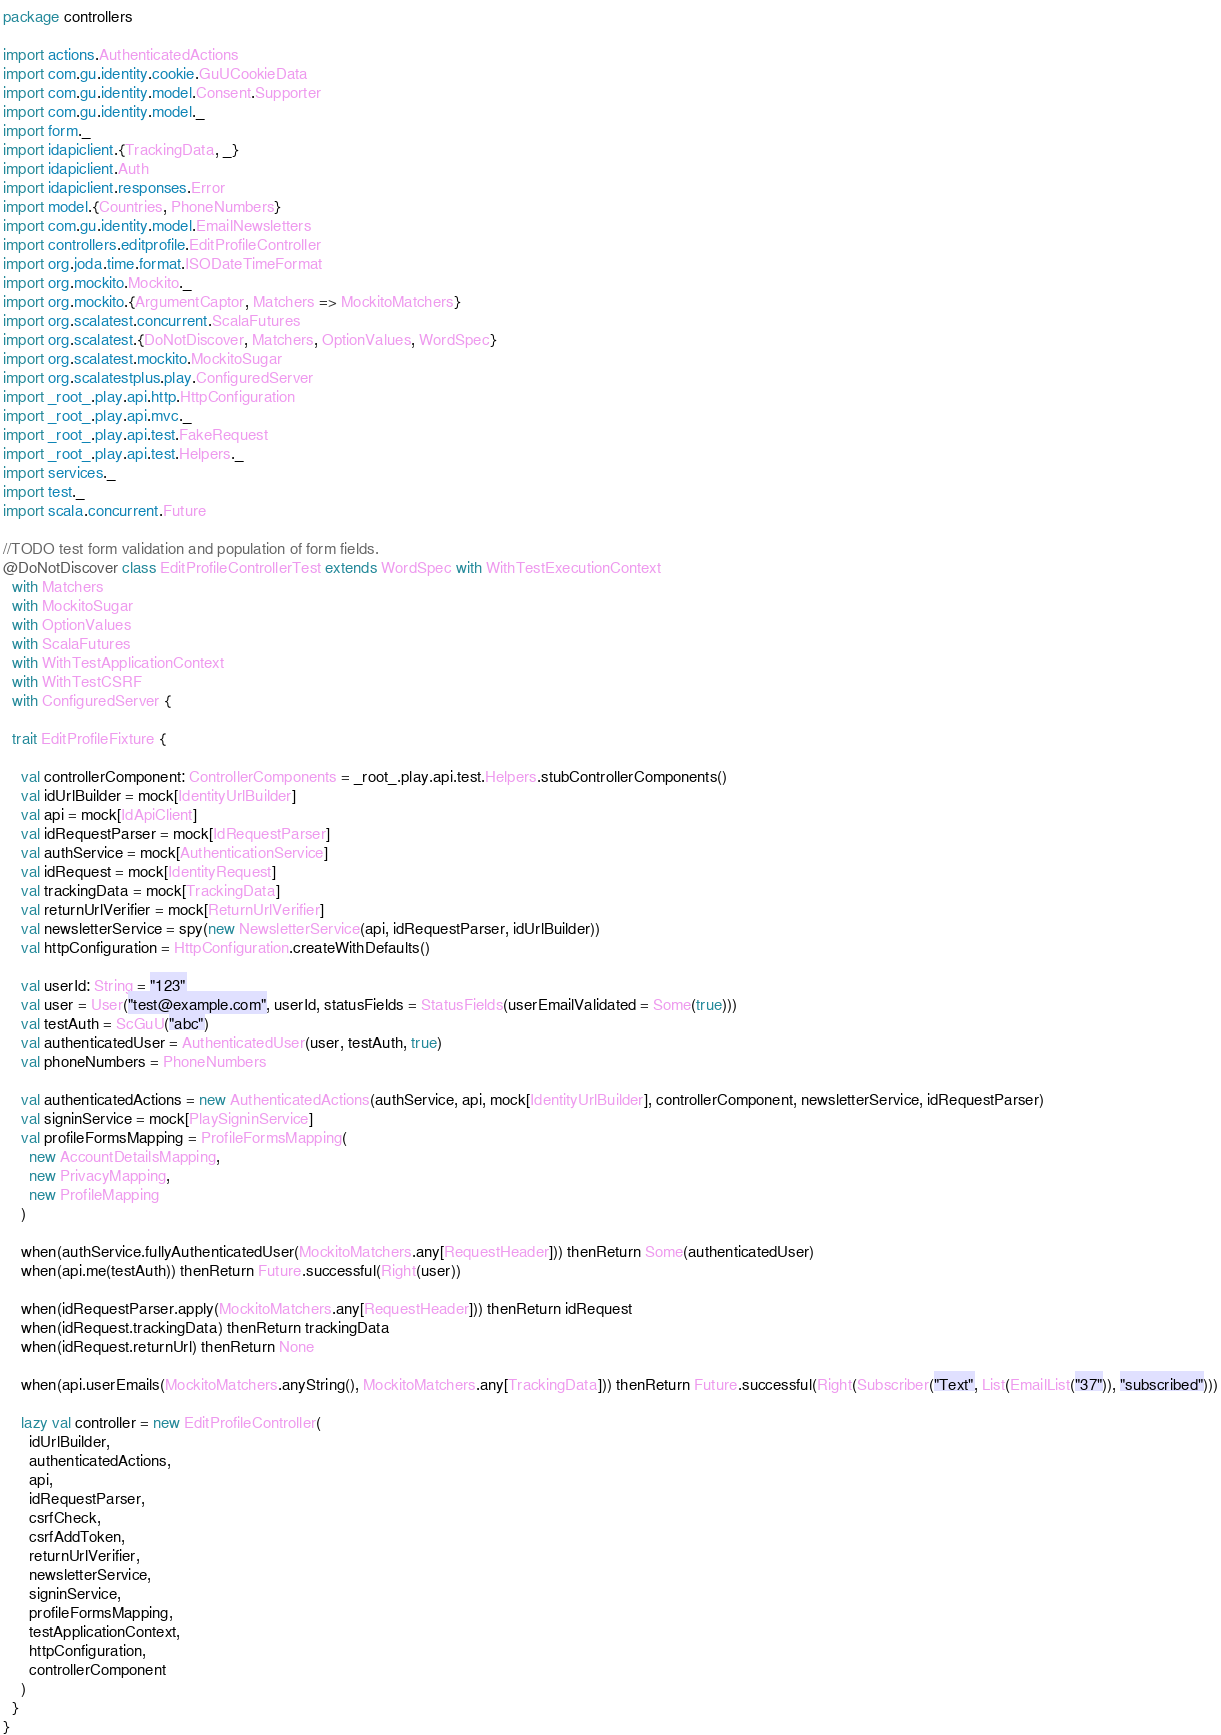Convert code to text. <code><loc_0><loc_0><loc_500><loc_500><_Scala_>package controllers

import actions.AuthenticatedActions
import com.gu.identity.cookie.GuUCookieData
import com.gu.identity.model.Consent.Supporter
import com.gu.identity.model._
import form._
import idapiclient.{TrackingData, _}
import idapiclient.Auth
import idapiclient.responses.Error
import model.{Countries, PhoneNumbers}
import com.gu.identity.model.EmailNewsletters
import controllers.editprofile.EditProfileController
import org.joda.time.format.ISODateTimeFormat
import org.mockito.Mockito._
import org.mockito.{ArgumentCaptor, Matchers => MockitoMatchers}
import org.scalatest.concurrent.ScalaFutures
import org.scalatest.{DoNotDiscover, Matchers, OptionValues, WordSpec}
import org.scalatest.mockito.MockitoSugar
import org.scalatestplus.play.ConfiguredServer
import _root_.play.api.http.HttpConfiguration
import _root_.play.api.mvc._
import _root_.play.api.test.FakeRequest
import _root_.play.api.test.Helpers._
import services._
import test._
import scala.concurrent.Future

//TODO test form validation and population of form fields.
@DoNotDiscover class EditProfileControllerTest extends WordSpec with WithTestExecutionContext
  with Matchers
  with MockitoSugar
  with OptionValues
  with ScalaFutures
  with WithTestApplicationContext
  with WithTestCSRF
  with ConfiguredServer {

  trait EditProfileFixture {

    val controllerComponent: ControllerComponents = _root_.play.api.test.Helpers.stubControllerComponents()
    val idUrlBuilder = mock[IdentityUrlBuilder]
    val api = mock[IdApiClient]
    val idRequestParser = mock[IdRequestParser]
    val authService = mock[AuthenticationService]
    val idRequest = mock[IdentityRequest]
    val trackingData = mock[TrackingData]
    val returnUrlVerifier = mock[ReturnUrlVerifier]
    val newsletterService = spy(new NewsletterService(api, idRequestParser, idUrlBuilder))
    val httpConfiguration = HttpConfiguration.createWithDefaults()

    val userId: String = "123"
    val user = User("test@example.com", userId, statusFields = StatusFields(userEmailValidated = Some(true)))
    val testAuth = ScGuU("abc")
    val authenticatedUser = AuthenticatedUser(user, testAuth, true)
    val phoneNumbers = PhoneNumbers

    val authenticatedActions = new AuthenticatedActions(authService, api, mock[IdentityUrlBuilder], controllerComponent, newsletterService, idRequestParser)
    val signinService = mock[PlaySigninService]
    val profileFormsMapping = ProfileFormsMapping(
      new AccountDetailsMapping,
      new PrivacyMapping,
      new ProfileMapping
    )

    when(authService.fullyAuthenticatedUser(MockitoMatchers.any[RequestHeader])) thenReturn Some(authenticatedUser)
    when(api.me(testAuth)) thenReturn Future.successful(Right(user))

    when(idRequestParser.apply(MockitoMatchers.any[RequestHeader])) thenReturn idRequest
    when(idRequest.trackingData) thenReturn trackingData
    when(idRequest.returnUrl) thenReturn None

    when(api.userEmails(MockitoMatchers.anyString(), MockitoMatchers.any[TrackingData])) thenReturn Future.successful(Right(Subscriber("Text", List(EmailList("37")), "subscribed")))

    lazy val controller = new EditProfileController(
      idUrlBuilder,
      authenticatedActions,
      api,
      idRequestParser,
      csrfCheck,
      csrfAddToken,
      returnUrlVerifier,
      newsletterService,
      signinService,
      profileFormsMapping,
      testApplicationContext,
      httpConfiguration,
      controllerComponent
    )
  }
}
</code> 